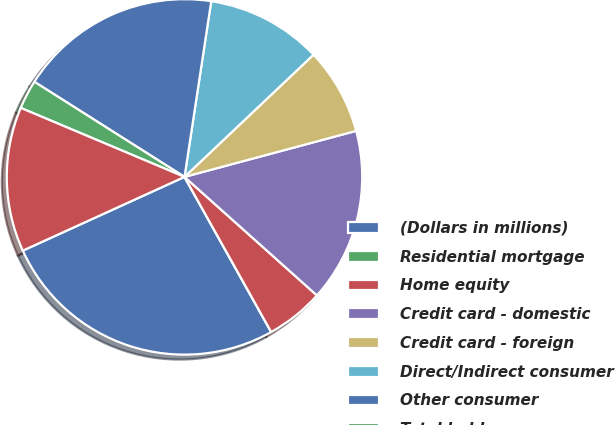<chart> <loc_0><loc_0><loc_500><loc_500><pie_chart><fcel>(Dollars in millions)<fcel>Residential mortgage<fcel>Home equity<fcel>Credit card - domestic<fcel>Credit card - foreign<fcel>Direct/Indirect consumer<fcel>Other consumer<fcel>Total held<fcel>Total credit card - managed<nl><fcel>26.31%<fcel>0.0%<fcel>5.27%<fcel>15.79%<fcel>7.9%<fcel>10.53%<fcel>18.42%<fcel>2.64%<fcel>13.16%<nl></chart> 